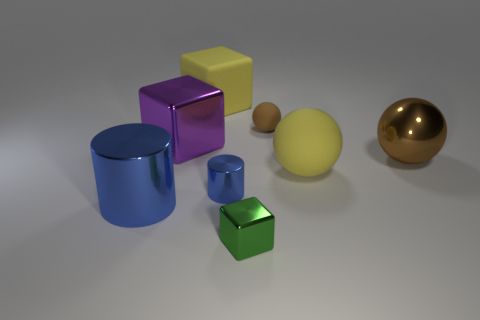Add 2 blue rubber spheres. How many objects exist? 10 Subtract all big spheres. How many spheres are left? 1 Subtract all yellow cubes. How many cubes are left? 2 Subtract all blocks. How many objects are left? 5 Subtract 2 cylinders. How many cylinders are left? 0 Subtract all cyan cylinders. How many green cubes are left? 1 Subtract all rubber spheres. Subtract all big blue cylinders. How many objects are left? 5 Add 7 big blue things. How many big blue things are left? 8 Add 7 big purple things. How many big purple things exist? 8 Subtract 1 yellow balls. How many objects are left? 7 